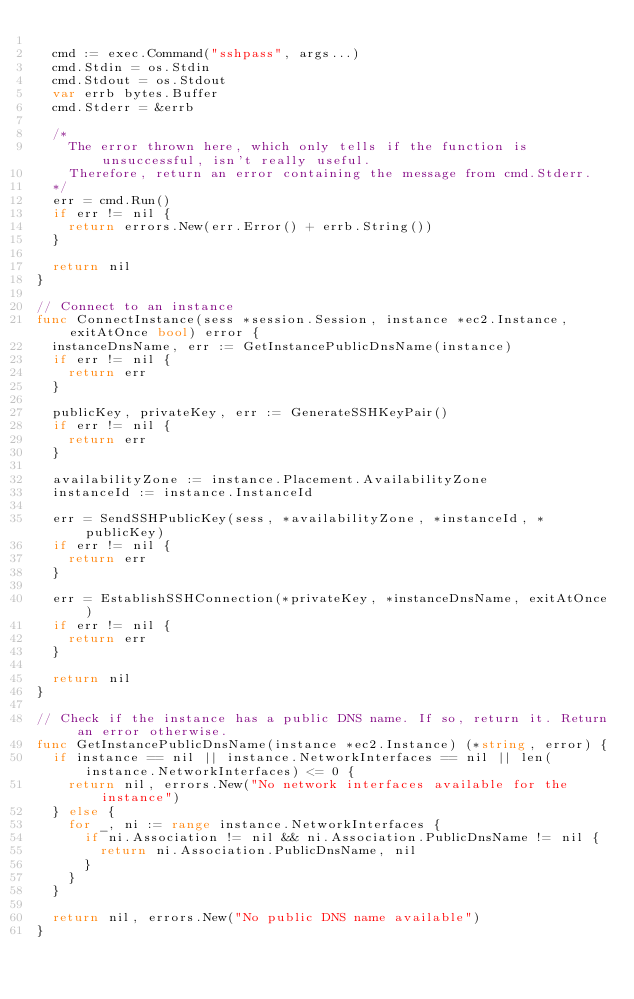<code> <loc_0><loc_0><loc_500><loc_500><_Go_>
	cmd := exec.Command("sshpass", args...)
	cmd.Stdin = os.Stdin
	cmd.Stdout = os.Stdout
	var errb bytes.Buffer
	cmd.Stderr = &errb

	/*
		The error thrown here, which only tells if the function is unsuccessful, isn't really useful.
		Therefore, return an error containing the message from cmd.Stderr.
	*/
	err = cmd.Run()
	if err != nil {
		return errors.New(err.Error() + errb.String())
	}

	return nil
}

// Connect to an instance
func ConnectInstance(sess *session.Session, instance *ec2.Instance, exitAtOnce bool) error {
	instanceDnsName, err := GetInstancePublicDnsName(instance)
	if err != nil {
		return err
	}

	publicKey, privateKey, err := GenerateSSHKeyPair()
	if err != nil {
		return err
	}

	availabilityZone := instance.Placement.AvailabilityZone
	instanceId := instance.InstanceId

	err = SendSSHPublicKey(sess, *availabilityZone, *instanceId, *publicKey)
	if err != nil {
		return err
	}

	err = EstablishSSHConnection(*privateKey, *instanceDnsName, exitAtOnce)
	if err != nil {
		return err
	}

	return nil
}

// Check if the instance has a public DNS name. If so, return it. Return an error otherwise.
func GetInstancePublicDnsName(instance *ec2.Instance) (*string, error) {
	if instance == nil || instance.NetworkInterfaces == nil || len(instance.NetworkInterfaces) <= 0 {
		return nil, errors.New("No network interfaces available for the instance")
	} else {
		for _, ni := range instance.NetworkInterfaces {
			if ni.Association != nil && ni.Association.PublicDnsName != nil {
				return ni.Association.PublicDnsName, nil
			}
		}
	}

	return nil, errors.New("No public DNS name available")
}
</code> 